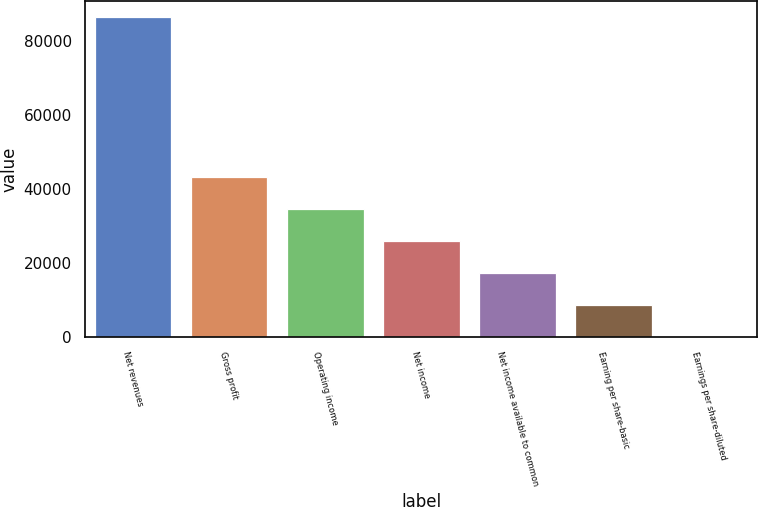Convert chart to OTSL. <chart><loc_0><loc_0><loc_500><loc_500><bar_chart><fcel>Net revenues<fcel>Gross profit<fcel>Operating income<fcel>Net income<fcel>Net income available to common<fcel>Earning per share-basic<fcel>Earnings per share-diluted<nl><fcel>86606<fcel>43303.1<fcel>34642.5<fcel>25981.9<fcel>17321.4<fcel>8660.78<fcel>0.2<nl></chart> 